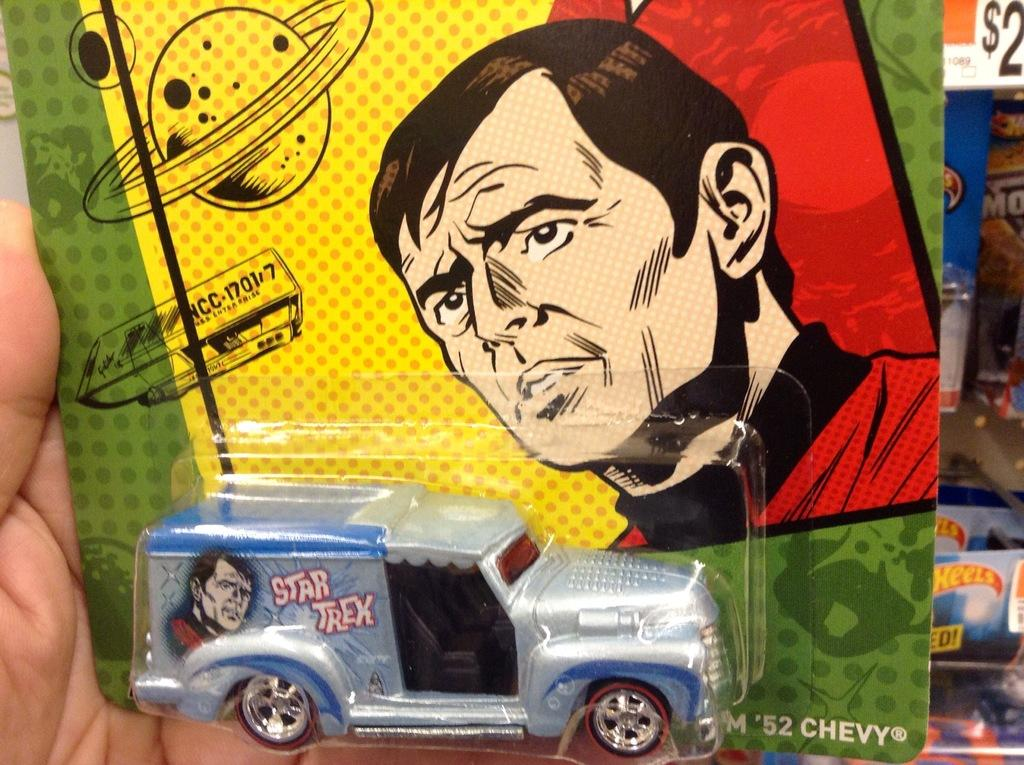What is the person in the image holding? The person is holding a package in the image. What is inside the package? The package contains a toy vehicle. What can be seen in the background of the image? There are boxes and a board in the background of the image. What type of friction can be observed between the toy vehicle and the board in the image? There is no friction between the toy vehicle and the board in the image, as the toy vehicle is inside the package and not interacting with the board. 